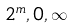<formula> <loc_0><loc_0><loc_500><loc_500>2 ^ { m } , 0 , \infty</formula> 